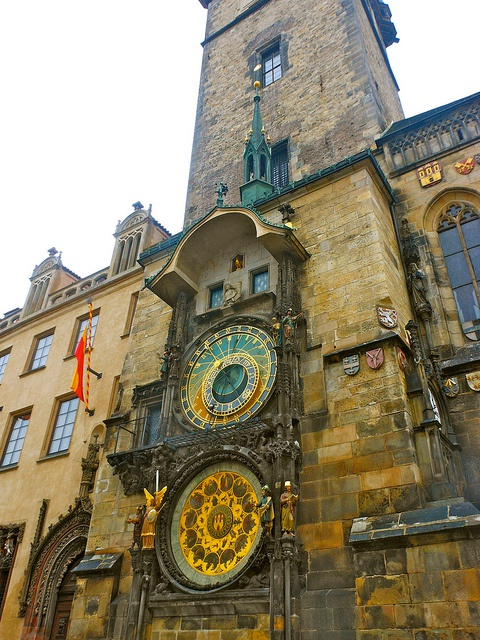Describe the objects in this image and their specific colors. I can see clock in white, olive, orange, and maroon tones and clock in white, olive, teal, and black tones in this image. 